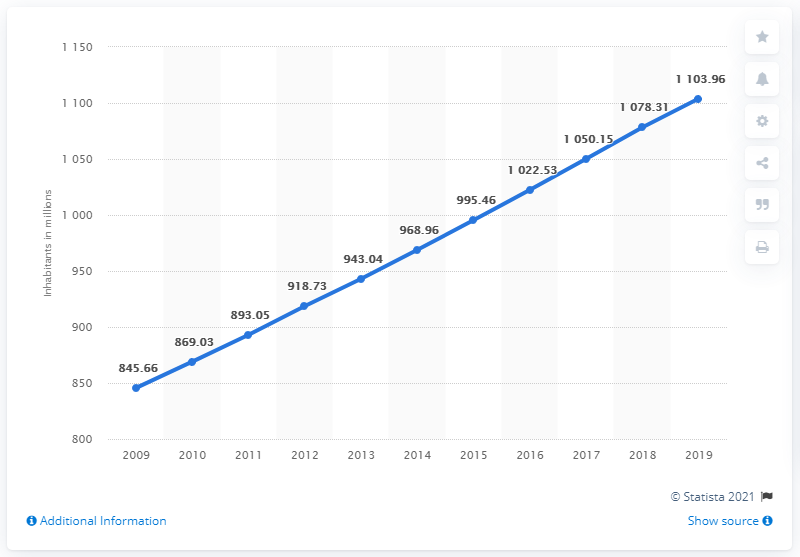List a handful of essential elements in this visual. In 2019, the population of Sub-Saharan Africa was 1,103.96 million. 